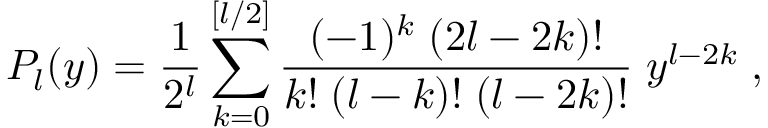<formula> <loc_0><loc_0><loc_500><loc_500>P _ { l } ( y ) = \frac { 1 } { 2 ^ { l } } \sum _ { k = 0 } ^ { [ l / 2 ] } \frac { ( - 1 ) ^ { k } \, ( 2 l - 2 k ) ! } { k ! \, ( l - k ) ! \, ( l - 2 k ) ! } \, y ^ { l - 2 k } \, ,</formula> 